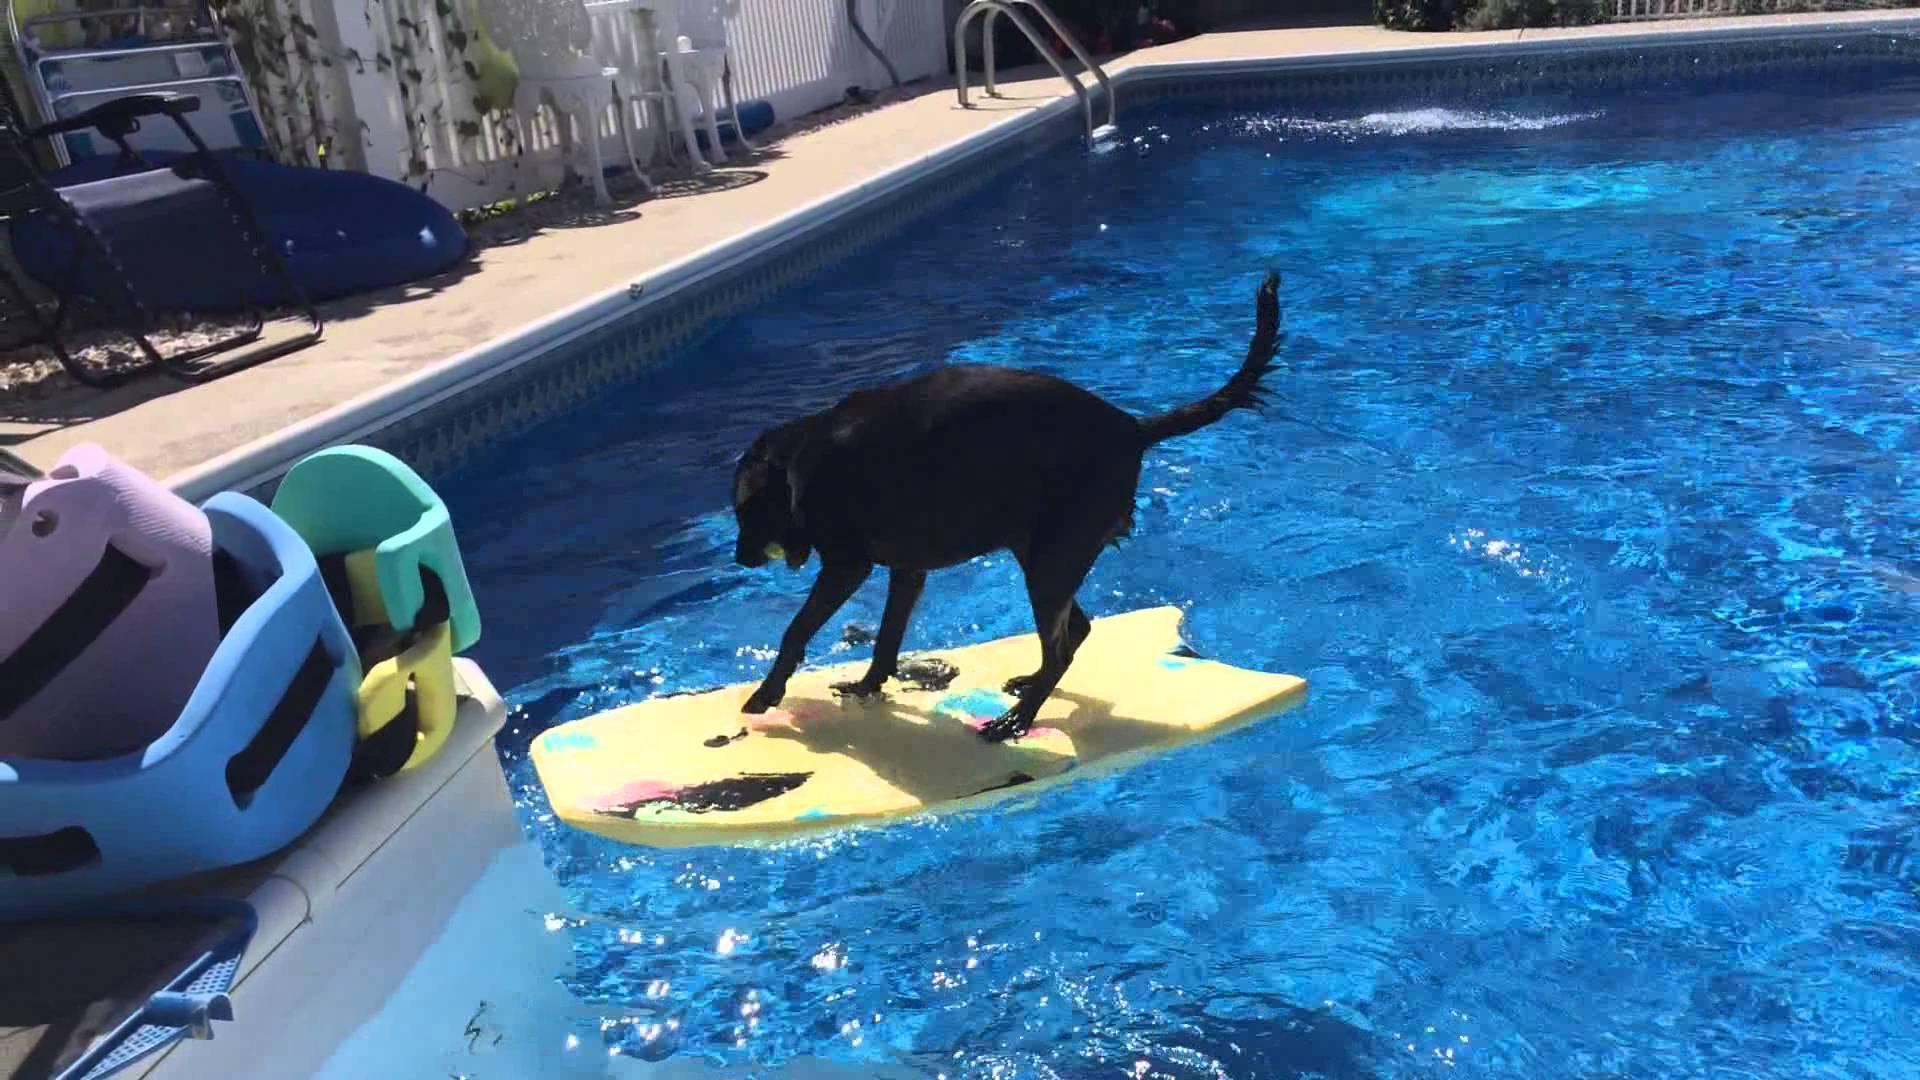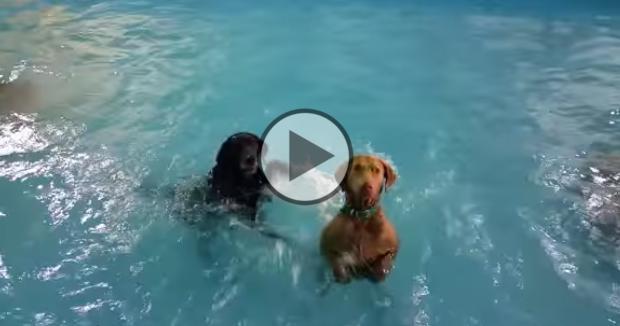The first image is the image on the left, the second image is the image on the right. Examine the images to the left and right. Is the description "A black dog is floating on something yellow in a pool." accurate? Answer yes or no. Yes. The first image is the image on the left, the second image is the image on the right. Assess this claim about the two images: "One dog is swimming.". Correct or not? Answer yes or no. No. 